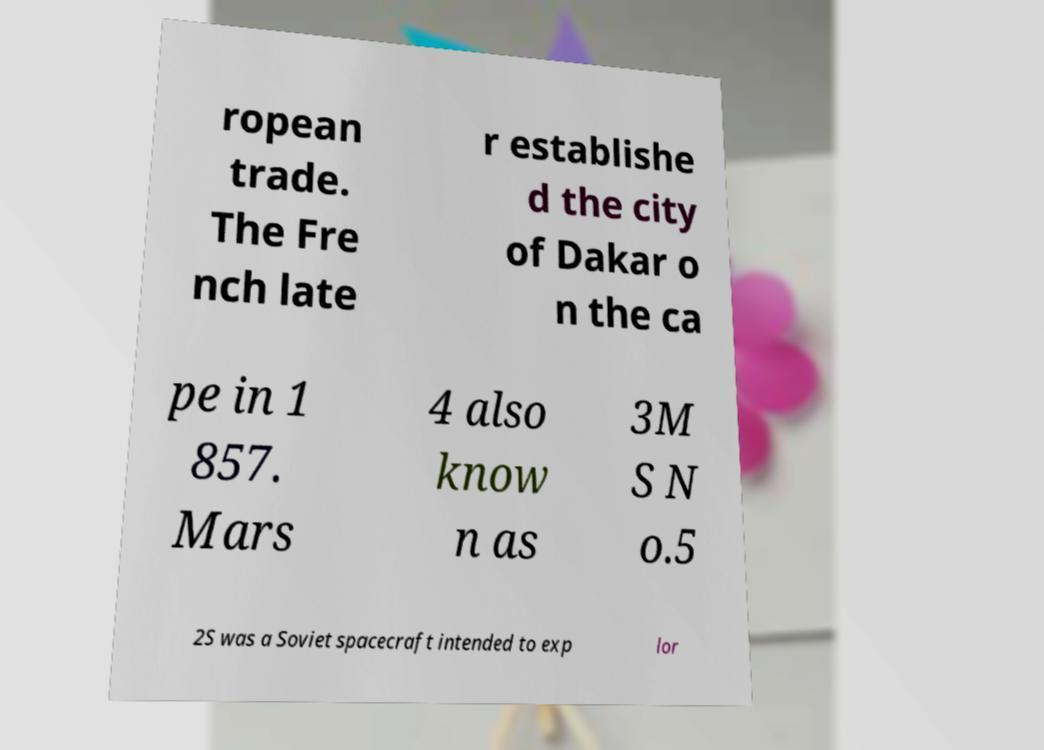Can you read and provide the text displayed in the image?This photo seems to have some interesting text. Can you extract and type it out for me? ropean trade. The Fre nch late r establishe d the city of Dakar o n the ca pe in 1 857. Mars 4 also know n as 3M S N o.5 2S was a Soviet spacecraft intended to exp lor 